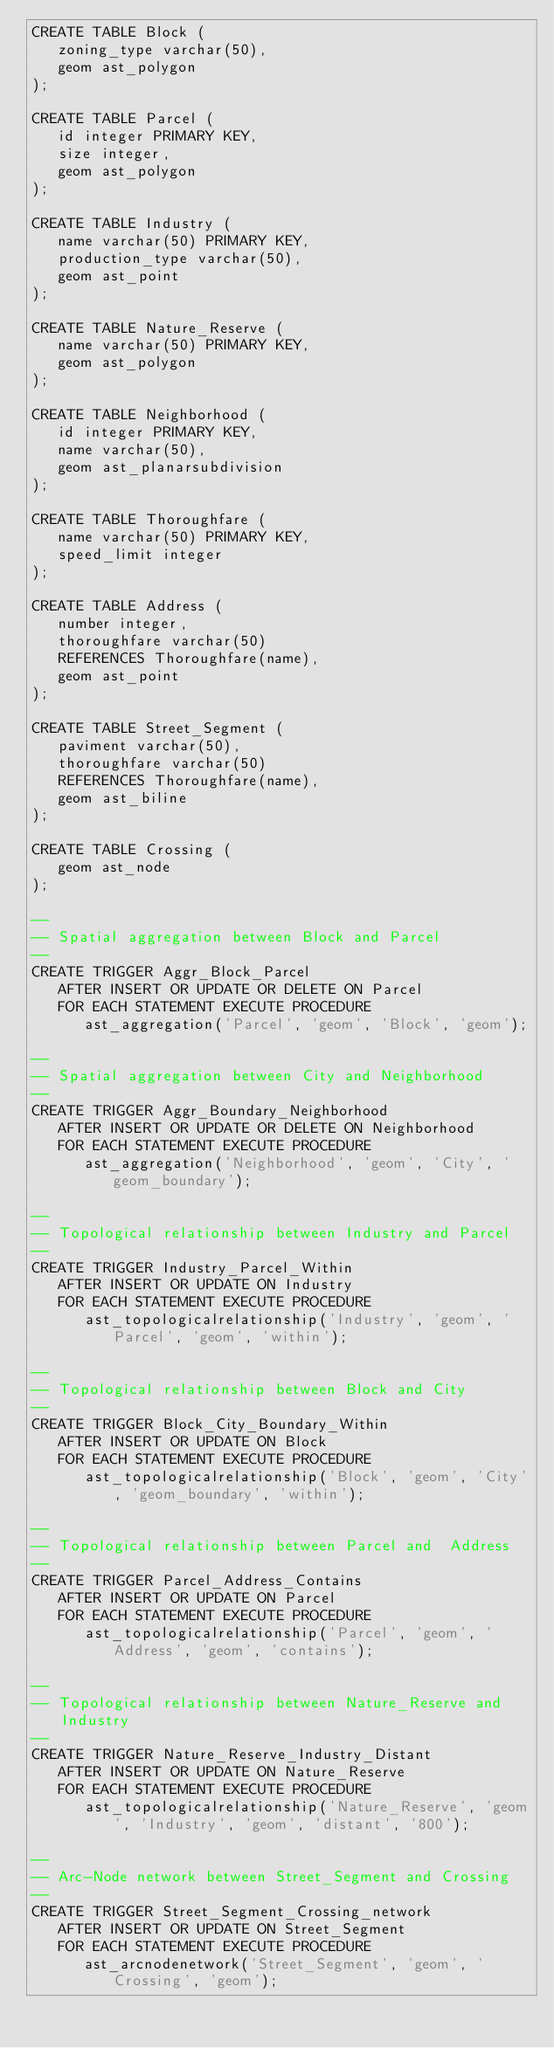<code> <loc_0><loc_0><loc_500><loc_500><_SQL_>CREATE TABLE Block (
   zoning_type varchar(50),
   geom ast_polygon
);

CREATE TABLE Parcel (
   id integer PRIMARY KEY,
   size integer,
   geom ast_polygon
);

CREATE TABLE Industry (
   name varchar(50) PRIMARY KEY,
   production_type varchar(50),
   geom ast_point
);

CREATE TABLE Nature_Reserve (
   name varchar(50) PRIMARY KEY,
   geom ast_polygon
);

CREATE TABLE Neighborhood (
   id integer PRIMARY KEY,
   name varchar(50),
   geom ast_planarsubdivision
);

CREATE TABLE Thoroughfare (
   name varchar(50) PRIMARY KEY,
   speed_limit integer
);

CREATE TABLE Address (
   number integer,
   thoroughfare varchar(50)
   REFERENCES Thoroughfare(name),
   geom ast_point
);

CREATE TABLE Street_Segment (
   paviment varchar(50),
   thoroughfare varchar(50)
   REFERENCES Thoroughfare(name),
   geom ast_biline
);

CREATE TABLE Crossing (
   geom ast_node
);

--
-- Spatial aggregation between Block and Parcel
--
CREATE TRIGGER Aggr_Block_Parcel
   AFTER INSERT OR UPDATE OR DELETE ON Parcel
   FOR EACH STATEMENT EXECUTE PROCEDURE
      ast_aggregation('Parcel', 'geom', 'Block', 'geom');

--
-- Spatial aggregation between City and Neighborhood
--
CREATE TRIGGER Aggr_Boundary_Neighborhood
   AFTER INSERT OR UPDATE OR DELETE ON Neighborhood
   FOR EACH STATEMENT EXECUTE PROCEDURE
      ast_aggregation('Neighborhood', 'geom', 'City', 'geom_boundary');

--
-- Topological relationship between Industry and Parcel
--
CREATE TRIGGER Industry_Parcel_Within
   AFTER INSERT OR UPDATE ON Industry
   FOR EACH STATEMENT EXECUTE PROCEDURE
      ast_topologicalrelationship('Industry', 'geom', 'Parcel', 'geom', 'within');

--
-- Topological relationship between Block and City
--
CREATE TRIGGER Block_City_Boundary_Within
   AFTER INSERT OR UPDATE ON Block
   FOR EACH STATEMENT EXECUTE PROCEDURE
      ast_topologicalrelationship('Block', 'geom', 'City', 'geom_boundary', 'within');

--
-- Topological relationship between Parcel and  Address
--
CREATE TRIGGER Parcel_Address_Contains
   AFTER INSERT OR UPDATE ON Parcel
   FOR EACH STATEMENT EXECUTE PROCEDURE
      ast_topologicalrelationship('Parcel', 'geom', 'Address', 'geom', 'contains');

--
-- Topological relationship between Nature_Reserve and Industry
--
CREATE TRIGGER Nature_Reserve_Industry_Distant
   AFTER INSERT OR UPDATE ON Nature_Reserve
   FOR EACH STATEMENT EXECUTE PROCEDURE
      ast_topologicalrelationship('Nature_Reserve', 'geom', 'Industry', 'geom', 'distant', '800');

--
-- Arc-Node network between Street_Segment and Crossing
--
CREATE TRIGGER Street_Segment_Crossing_network
   AFTER INSERT OR UPDATE ON Street_Segment
   FOR EACH STATEMENT EXECUTE PROCEDURE
      ast_arcnodenetwork('Street_Segment', 'geom', 'Crossing', 'geom');
</code> 